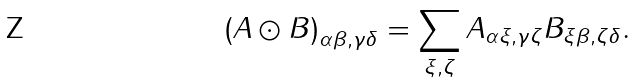<formula> <loc_0><loc_0><loc_500><loc_500>\left ( A \odot B \right ) _ { \alpha \beta , \gamma \delta } = \sum _ { \xi , \zeta } A _ { \alpha \xi , \gamma \zeta } B _ { \xi \beta , \zeta \delta } .</formula> 